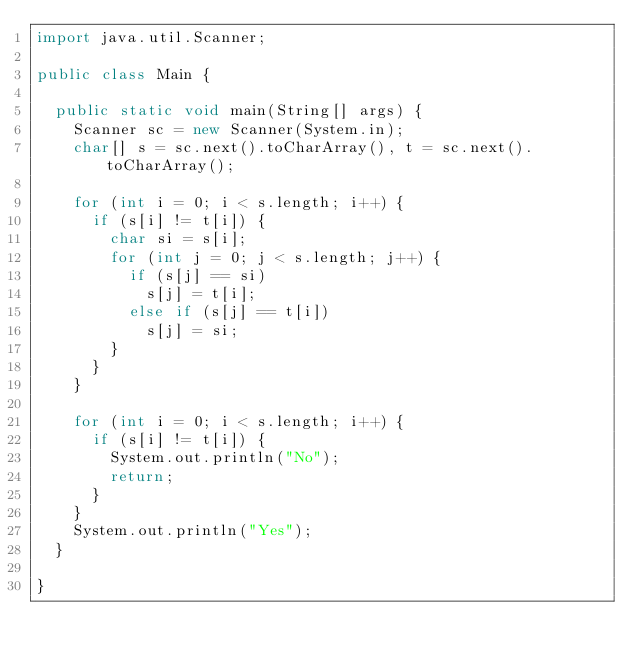<code> <loc_0><loc_0><loc_500><loc_500><_Java_>import java.util.Scanner;

public class Main {

	public static void main(String[] args) {
		Scanner sc = new Scanner(System.in);
		char[] s = sc.next().toCharArray(), t = sc.next().toCharArray();
		
		for (int i = 0; i < s.length; i++) {
			if (s[i] != t[i]) {
				char si = s[i];
				for (int j = 0; j < s.length; j++) {
					if (s[j] == si)
						s[j] = t[i];
					else if (s[j] == t[i])
						s[j] = si;
				}
			}
		}
		
		for (int i = 0; i < s.length; i++) {
			if (s[i] != t[i]) {
				System.out.println("No");
				return;
			}
		}
		System.out.println("Yes");
	}

}</code> 